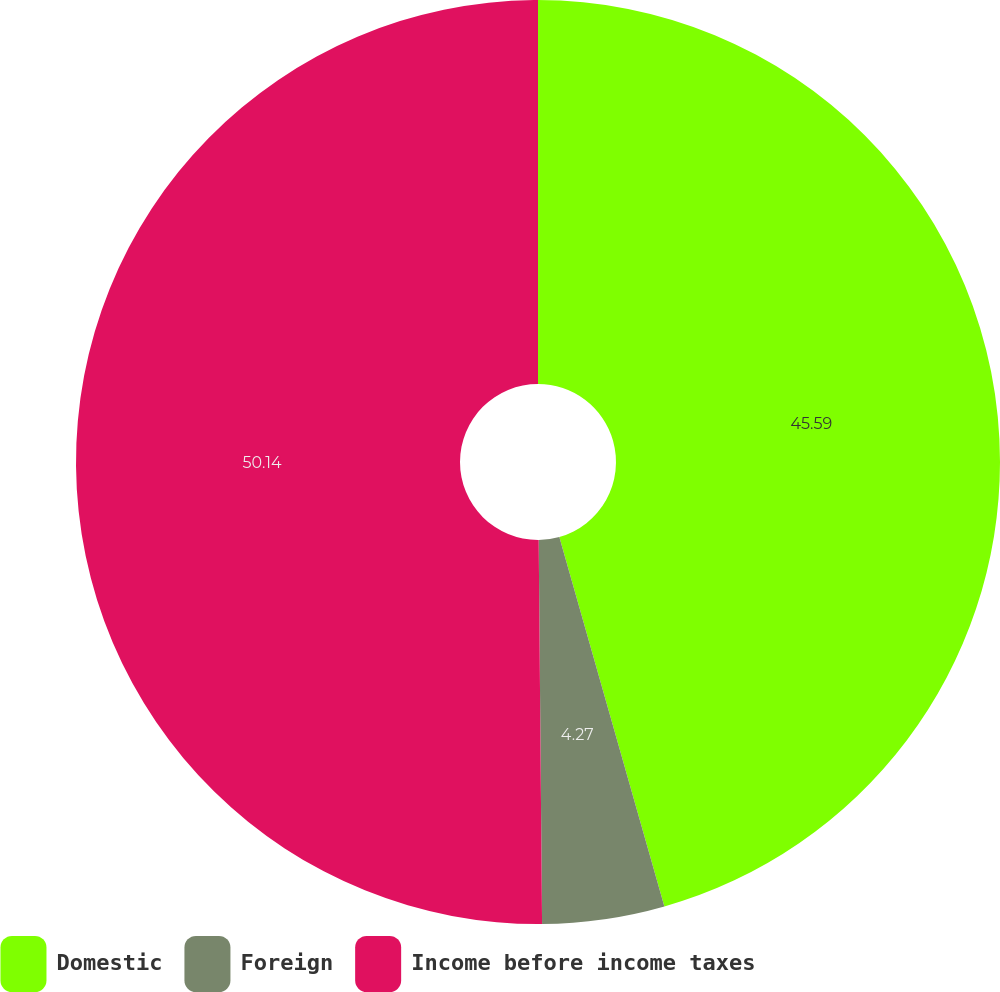<chart> <loc_0><loc_0><loc_500><loc_500><pie_chart><fcel>Domestic<fcel>Foreign<fcel>Income before income taxes<nl><fcel>45.59%<fcel>4.27%<fcel>50.14%<nl></chart> 